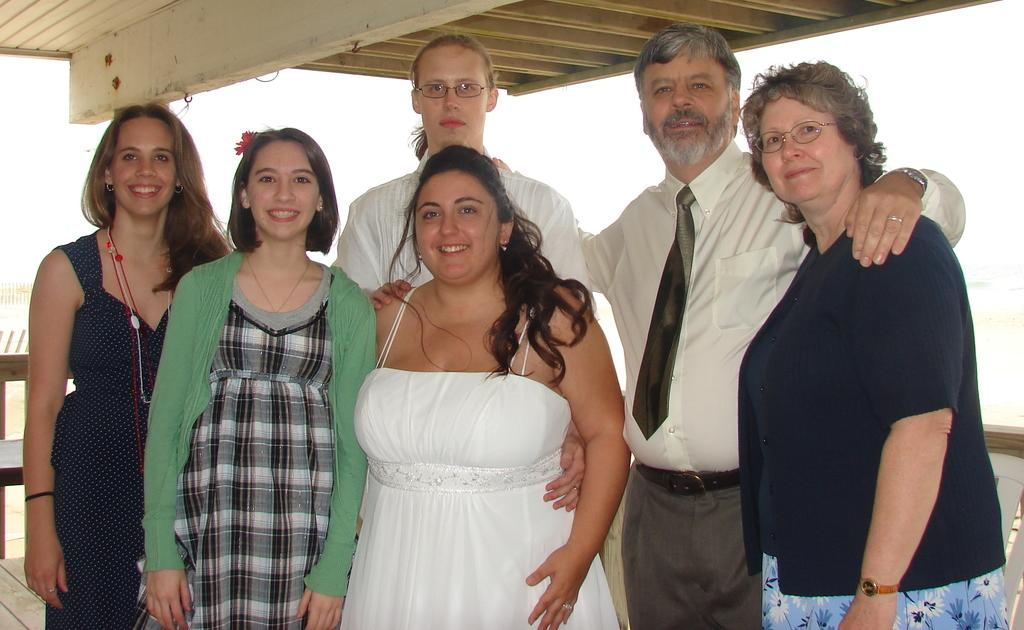How many people are in the image? There are six people in the image, including four women and two men. What are the people in the image doing? The people are posing for a photograph. What type of feather can be seen in the image? There is no feather present in the image. What instrument is the man playing in the image? There is no instrument or drum present in the image. 